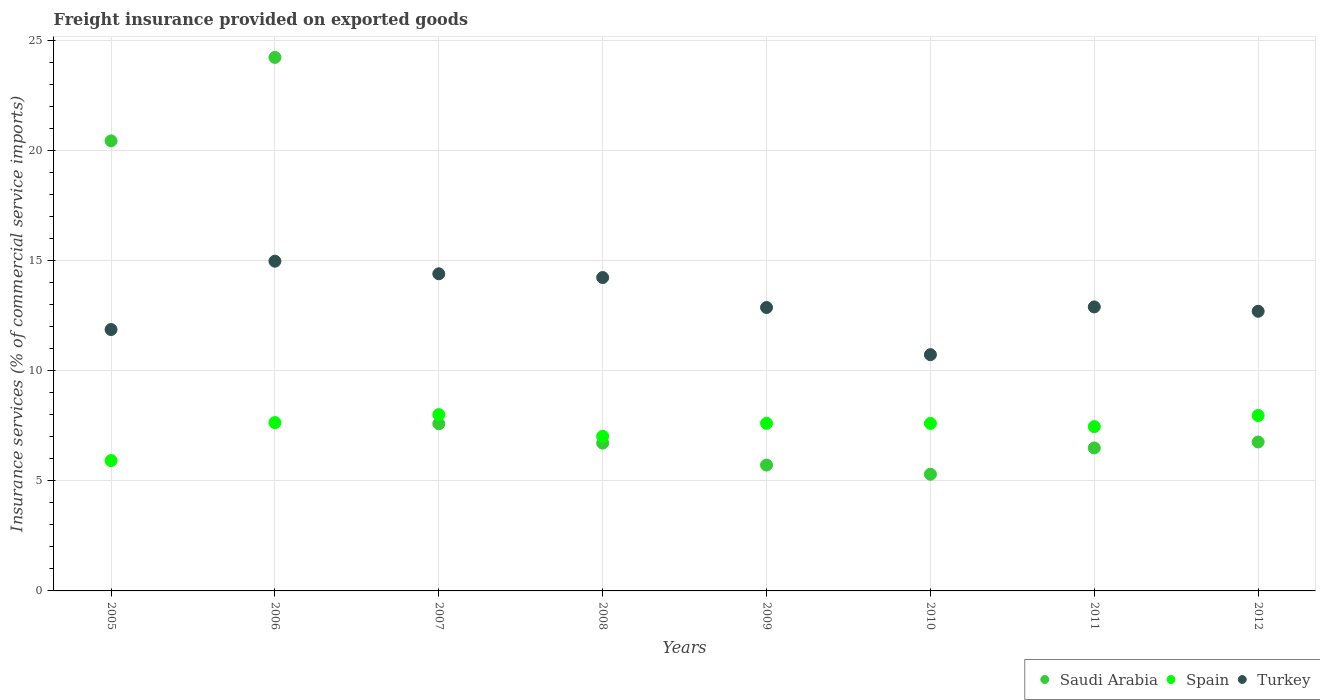What is the freight insurance provided on exported goods in Turkey in 2010?
Make the answer very short. 10.73. Across all years, what is the maximum freight insurance provided on exported goods in Saudi Arabia?
Make the answer very short. 24.23. Across all years, what is the minimum freight insurance provided on exported goods in Saudi Arabia?
Offer a terse response. 5.3. In which year was the freight insurance provided on exported goods in Saudi Arabia minimum?
Keep it short and to the point. 2010. What is the total freight insurance provided on exported goods in Turkey in the graph?
Your answer should be compact. 104.69. What is the difference between the freight insurance provided on exported goods in Spain in 2005 and that in 2006?
Provide a short and direct response. -1.73. What is the difference between the freight insurance provided on exported goods in Spain in 2005 and the freight insurance provided on exported goods in Turkey in 2010?
Your answer should be very brief. -4.81. What is the average freight insurance provided on exported goods in Spain per year?
Keep it short and to the point. 7.41. In the year 2009, what is the difference between the freight insurance provided on exported goods in Turkey and freight insurance provided on exported goods in Spain?
Your response must be concise. 5.26. What is the ratio of the freight insurance provided on exported goods in Turkey in 2008 to that in 2011?
Provide a short and direct response. 1.1. What is the difference between the highest and the second highest freight insurance provided on exported goods in Turkey?
Your answer should be very brief. 0.57. What is the difference between the highest and the lowest freight insurance provided on exported goods in Turkey?
Offer a very short reply. 4.25. In how many years, is the freight insurance provided on exported goods in Turkey greater than the average freight insurance provided on exported goods in Turkey taken over all years?
Your response must be concise. 3. Is the sum of the freight insurance provided on exported goods in Saudi Arabia in 2011 and 2012 greater than the maximum freight insurance provided on exported goods in Spain across all years?
Keep it short and to the point. Yes. Is it the case that in every year, the sum of the freight insurance provided on exported goods in Spain and freight insurance provided on exported goods in Saudi Arabia  is greater than the freight insurance provided on exported goods in Turkey?
Make the answer very short. No. Does the freight insurance provided on exported goods in Spain monotonically increase over the years?
Provide a succinct answer. No. Is the freight insurance provided on exported goods in Saudi Arabia strictly greater than the freight insurance provided on exported goods in Turkey over the years?
Keep it short and to the point. No. How many dotlines are there?
Give a very brief answer. 3. How many years are there in the graph?
Keep it short and to the point. 8. What is the difference between two consecutive major ticks on the Y-axis?
Your answer should be very brief. 5. Are the values on the major ticks of Y-axis written in scientific E-notation?
Offer a very short reply. No. Does the graph contain grids?
Give a very brief answer. Yes. What is the title of the graph?
Offer a terse response. Freight insurance provided on exported goods. What is the label or title of the Y-axis?
Ensure brevity in your answer.  Insurance services (% of commercial service imports). What is the Insurance services (% of commercial service imports) of Saudi Arabia in 2005?
Offer a very short reply. 20.44. What is the Insurance services (% of commercial service imports) in Spain in 2005?
Offer a terse response. 5.92. What is the Insurance services (% of commercial service imports) of Turkey in 2005?
Your answer should be compact. 11.87. What is the Insurance services (% of commercial service imports) of Saudi Arabia in 2006?
Make the answer very short. 24.23. What is the Insurance services (% of commercial service imports) in Spain in 2006?
Give a very brief answer. 7.65. What is the Insurance services (% of commercial service imports) of Turkey in 2006?
Offer a terse response. 14.98. What is the Insurance services (% of commercial service imports) of Saudi Arabia in 2007?
Your response must be concise. 7.59. What is the Insurance services (% of commercial service imports) of Spain in 2007?
Your answer should be very brief. 8.01. What is the Insurance services (% of commercial service imports) in Turkey in 2007?
Offer a terse response. 14.4. What is the Insurance services (% of commercial service imports) in Saudi Arabia in 2008?
Your answer should be very brief. 6.71. What is the Insurance services (% of commercial service imports) in Spain in 2008?
Give a very brief answer. 7.02. What is the Insurance services (% of commercial service imports) of Turkey in 2008?
Keep it short and to the point. 14.23. What is the Insurance services (% of commercial service imports) in Saudi Arabia in 2009?
Provide a succinct answer. 5.72. What is the Insurance services (% of commercial service imports) of Spain in 2009?
Ensure brevity in your answer.  7.61. What is the Insurance services (% of commercial service imports) of Turkey in 2009?
Provide a succinct answer. 12.87. What is the Insurance services (% of commercial service imports) in Saudi Arabia in 2010?
Provide a short and direct response. 5.3. What is the Insurance services (% of commercial service imports) of Spain in 2010?
Make the answer very short. 7.61. What is the Insurance services (% of commercial service imports) of Turkey in 2010?
Your answer should be very brief. 10.73. What is the Insurance services (% of commercial service imports) in Saudi Arabia in 2011?
Your response must be concise. 6.49. What is the Insurance services (% of commercial service imports) in Spain in 2011?
Ensure brevity in your answer.  7.46. What is the Insurance services (% of commercial service imports) of Turkey in 2011?
Provide a short and direct response. 12.9. What is the Insurance services (% of commercial service imports) in Saudi Arabia in 2012?
Provide a succinct answer. 6.76. What is the Insurance services (% of commercial service imports) of Spain in 2012?
Your response must be concise. 7.97. What is the Insurance services (% of commercial service imports) in Turkey in 2012?
Ensure brevity in your answer.  12.7. Across all years, what is the maximum Insurance services (% of commercial service imports) in Saudi Arabia?
Provide a succinct answer. 24.23. Across all years, what is the maximum Insurance services (% of commercial service imports) in Spain?
Give a very brief answer. 8.01. Across all years, what is the maximum Insurance services (% of commercial service imports) in Turkey?
Your response must be concise. 14.98. Across all years, what is the minimum Insurance services (% of commercial service imports) in Saudi Arabia?
Provide a short and direct response. 5.3. Across all years, what is the minimum Insurance services (% of commercial service imports) of Spain?
Make the answer very short. 5.92. Across all years, what is the minimum Insurance services (% of commercial service imports) of Turkey?
Ensure brevity in your answer.  10.73. What is the total Insurance services (% of commercial service imports) of Saudi Arabia in the graph?
Your response must be concise. 83.25. What is the total Insurance services (% of commercial service imports) in Spain in the graph?
Offer a very short reply. 59.25. What is the total Insurance services (% of commercial service imports) of Turkey in the graph?
Make the answer very short. 104.69. What is the difference between the Insurance services (% of commercial service imports) of Saudi Arabia in 2005 and that in 2006?
Give a very brief answer. -3.79. What is the difference between the Insurance services (% of commercial service imports) of Spain in 2005 and that in 2006?
Provide a short and direct response. -1.73. What is the difference between the Insurance services (% of commercial service imports) of Turkey in 2005 and that in 2006?
Your answer should be very brief. -3.1. What is the difference between the Insurance services (% of commercial service imports) of Saudi Arabia in 2005 and that in 2007?
Your answer should be compact. 12.85. What is the difference between the Insurance services (% of commercial service imports) in Spain in 2005 and that in 2007?
Your answer should be compact. -2.09. What is the difference between the Insurance services (% of commercial service imports) of Turkey in 2005 and that in 2007?
Your response must be concise. -2.53. What is the difference between the Insurance services (% of commercial service imports) of Saudi Arabia in 2005 and that in 2008?
Provide a succinct answer. 13.73. What is the difference between the Insurance services (% of commercial service imports) of Spain in 2005 and that in 2008?
Give a very brief answer. -1.1. What is the difference between the Insurance services (% of commercial service imports) of Turkey in 2005 and that in 2008?
Make the answer very short. -2.36. What is the difference between the Insurance services (% of commercial service imports) in Saudi Arabia in 2005 and that in 2009?
Provide a short and direct response. 14.73. What is the difference between the Insurance services (% of commercial service imports) in Spain in 2005 and that in 2009?
Give a very brief answer. -1.69. What is the difference between the Insurance services (% of commercial service imports) of Turkey in 2005 and that in 2009?
Ensure brevity in your answer.  -1. What is the difference between the Insurance services (% of commercial service imports) of Saudi Arabia in 2005 and that in 2010?
Your response must be concise. 15.14. What is the difference between the Insurance services (% of commercial service imports) in Spain in 2005 and that in 2010?
Keep it short and to the point. -1.69. What is the difference between the Insurance services (% of commercial service imports) of Turkey in 2005 and that in 2010?
Give a very brief answer. 1.14. What is the difference between the Insurance services (% of commercial service imports) in Saudi Arabia in 2005 and that in 2011?
Your answer should be compact. 13.95. What is the difference between the Insurance services (% of commercial service imports) of Spain in 2005 and that in 2011?
Your answer should be very brief. -1.54. What is the difference between the Insurance services (% of commercial service imports) of Turkey in 2005 and that in 2011?
Your answer should be compact. -1.03. What is the difference between the Insurance services (% of commercial service imports) in Saudi Arabia in 2005 and that in 2012?
Give a very brief answer. 13.68. What is the difference between the Insurance services (% of commercial service imports) of Spain in 2005 and that in 2012?
Your answer should be compact. -2.05. What is the difference between the Insurance services (% of commercial service imports) of Turkey in 2005 and that in 2012?
Offer a terse response. -0.83. What is the difference between the Insurance services (% of commercial service imports) of Saudi Arabia in 2006 and that in 2007?
Give a very brief answer. 16.64. What is the difference between the Insurance services (% of commercial service imports) of Spain in 2006 and that in 2007?
Keep it short and to the point. -0.36. What is the difference between the Insurance services (% of commercial service imports) in Turkey in 2006 and that in 2007?
Give a very brief answer. 0.57. What is the difference between the Insurance services (% of commercial service imports) of Saudi Arabia in 2006 and that in 2008?
Provide a succinct answer. 17.52. What is the difference between the Insurance services (% of commercial service imports) of Spain in 2006 and that in 2008?
Provide a short and direct response. 0.62. What is the difference between the Insurance services (% of commercial service imports) of Turkey in 2006 and that in 2008?
Your answer should be compact. 0.74. What is the difference between the Insurance services (% of commercial service imports) of Saudi Arabia in 2006 and that in 2009?
Make the answer very short. 18.52. What is the difference between the Insurance services (% of commercial service imports) of Spain in 2006 and that in 2009?
Ensure brevity in your answer.  0.03. What is the difference between the Insurance services (% of commercial service imports) of Turkey in 2006 and that in 2009?
Provide a short and direct response. 2.1. What is the difference between the Insurance services (% of commercial service imports) in Saudi Arabia in 2006 and that in 2010?
Provide a short and direct response. 18.93. What is the difference between the Insurance services (% of commercial service imports) of Spain in 2006 and that in 2010?
Your answer should be very brief. 0.04. What is the difference between the Insurance services (% of commercial service imports) in Turkey in 2006 and that in 2010?
Give a very brief answer. 4.25. What is the difference between the Insurance services (% of commercial service imports) of Saudi Arabia in 2006 and that in 2011?
Your answer should be compact. 17.74. What is the difference between the Insurance services (% of commercial service imports) of Spain in 2006 and that in 2011?
Your answer should be compact. 0.18. What is the difference between the Insurance services (% of commercial service imports) in Turkey in 2006 and that in 2011?
Provide a short and direct response. 2.08. What is the difference between the Insurance services (% of commercial service imports) of Saudi Arabia in 2006 and that in 2012?
Make the answer very short. 17.47. What is the difference between the Insurance services (% of commercial service imports) of Spain in 2006 and that in 2012?
Make the answer very short. -0.32. What is the difference between the Insurance services (% of commercial service imports) in Turkey in 2006 and that in 2012?
Give a very brief answer. 2.27. What is the difference between the Insurance services (% of commercial service imports) in Saudi Arabia in 2007 and that in 2008?
Your answer should be very brief. 0.88. What is the difference between the Insurance services (% of commercial service imports) of Spain in 2007 and that in 2008?
Offer a very short reply. 0.99. What is the difference between the Insurance services (% of commercial service imports) of Turkey in 2007 and that in 2008?
Keep it short and to the point. 0.17. What is the difference between the Insurance services (% of commercial service imports) in Saudi Arabia in 2007 and that in 2009?
Give a very brief answer. 1.88. What is the difference between the Insurance services (% of commercial service imports) of Spain in 2007 and that in 2009?
Your answer should be very brief. 0.4. What is the difference between the Insurance services (% of commercial service imports) of Turkey in 2007 and that in 2009?
Provide a succinct answer. 1.53. What is the difference between the Insurance services (% of commercial service imports) in Saudi Arabia in 2007 and that in 2010?
Provide a succinct answer. 2.29. What is the difference between the Insurance services (% of commercial service imports) of Spain in 2007 and that in 2010?
Your response must be concise. 0.4. What is the difference between the Insurance services (% of commercial service imports) in Turkey in 2007 and that in 2010?
Offer a terse response. 3.67. What is the difference between the Insurance services (% of commercial service imports) of Saudi Arabia in 2007 and that in 2011?
Offer a terse response. 1.1. What is the difference between the Insurance services (% of commercial service imports) in Spain in 2007 and that in 2011?
Provide a succinct answer. 0.55. What is the difference between the Insurance services (% of commercial service imports) of Turkey in 2007 and that in 2011?
Keep it short and to the point. 1.5. What is the difference between the Insurance services (% of commercial service imports) in Saudi Arabia in 2007 and that in 2012?
Your answer should be compact. 0.83. What is the difference between the Insurance services (% of commercial service imports) in Spain in 2007 and that in 2012?
Provide a short and direct response. 0.04. What is the difference between the Insurance services (% of commercial service imports) of Turkey in 2007 and that in 2012?
Your response must be concise. 1.7. What is the difference between the Insurance services (% of commercial service imports) in Spain in 2008 and that in 2009?
Provide a succinct answer. -0.59. What is the difference between the Insurance services (% of commercial service imports) in Turkey in 2008 and that in 2009?
Make the answer very short. 1.36. What is the difference between the Insurance services (% of commercial service imports) in Saudi Arabia in 2008 and that in 2010?
Keep it short and to the point. 1.41. What is the difference between the Insurance services (% of commercial service imports) in Spain in 2008 and that in 2010?
Make the answer very short. -0.59. What is the difference between the Insurance services (% of commercial service imports) of Turkey in 2008 and that in 2010?
Keep it short and to the point. 3.5. What is the difference between the Insurance services (% of commercial service imports) in Saudi Arabia in 2008 and that in 2011?
Provide a short and direct response. 0.22. What is the difference between the Insurance services (% of commercial service imports) in Spain in 2008 and that in 2011?
Offer a very short reply. -0.44. What is the difference between the Insurance services (% of commercial service imports) in Turkey in 2008 and that in 2011?
Give a very brief answer. 1.33. What is the difference between the Insurance services (% of commercial service imports) in Saudi Arabia in 2008 and that in 2012?
Your answer should be compact. -0.05. What is the difference between the Insurance services (% of commercial service imports) in Spain in 2008 and that in 2012?
Ensure brevity in your answer.  -0.95. What is the difference between the Insurance services (% of commercial service imports) of Turkey in 2008 and that in 2012?
Your response must be concise. 1.53. What is the difference between the Insurance services (% of commercial service imports) of Saudi Arabia in 2009 and that in 2010?
Ensure brevity in your answer.  0.42. What is the difference between the Insurance services (% of commercial service imports) in Spain in 2009 and that in 2010?
Make the answer very short. 0. What is the difference between the Insurance services (% of commercial service imports) of Turkey in 2009 and that in 2010?
Keep it short and to the point. 2.14. What is the difference between the Insurance services (% of commercial service imports) in Saudi Arabia in 2009 and that in 2011?
Ensure brevity in your answer.  -0.78. What is the difference between the Insurance services (% of commercial service imports) in Spain in 2009 and that in 2011?
Your response must be concise. 0.15. What is the difference between the Insurance services (% of commercial service imports) in Turkey in 2009 and that in 2011?
Offer a terse response. -0.03. What is the difference between the Insurance services (% of commercial service imports) in Saudi Arabia in 2009 and that in 2012?
Offer a very short reply. -1.05. What is the difference between the Insurance services (% of commercial service imports) of Spain in 2009 and that in 2012?
Provide a succinct answer. -0.35. What is the difference between the Insurance services (% of commercial service imports) of Turkey in 2009 and that in 2012?
Your response must be concise. 0.17. What is the difference between the Insurance services (% of commercial service imports) of Saudi Arabia in 2010 and that in 2011?
Provide a short and direct response. -1.19. What is the difference between the Insurance services (% of commercial service imports) of Spain in 2010 and that in 2011?
Provide a short and direct response. 0.15. What is the difference between the Insurance services (% of commercial service imports) in Turkey in 2010 and that in 2011?
Give a very brief answer. -2.17. What is the difference between the Insurance services (% of commercial service imports) in Saudi Arabia in 2010 and that in 2012?
Ensure brevity in your answer.  -1.46. What is the difference between the Insurance services (% of commercial service imports) of Spain in 2010 and that in 2012?
Your answer should be compact. -0.36. What is the difference between the Insurance services (% of commercial service imports) in Turkey in 2010 and that in 2012?
Make the answer very short. -1.97. What is the difference between the Insurance services (% of commercial service imports) of Saudi Arabia in 2011 and that in 2012?
Make the answer very short. -0.27. What is the difference between the Insurance services (% of commercial service imports) of Spain in 2011 and that in 2012?
Give a very brief answer. -0.5. What is the difference between the Insurance services (% of commercial service imports) in Turkey in 2011 and that in 2012?
Offer a very short reply. 0.2. What is the difference between the Insurance services (% of commercial service imports) of Saudi Arabia in 2005 and the Insurance services (% of commercial service imports) of Spain in 2006?
Offer a very short reply. 12.8. What is the difference between the Insurance services (% of commercial service imports) of Saudi Arabia in 2005 and the Insurance services (% of commercial service imports) of Turkey in 2006?
Make the answer very short. 5.46. What is the difference between the Insurance services (% of commercial service imports) in Spain in 2005 and the Insurance services (% of commercial service imports) in Turkey in 2006?
Your response must be concise. -9.06. What is the difference between the Insurance services (% of commercial service imports) in Saudi Arabia in 2005 and the Insurance services (% of commercial service imports) in Spain in 2007?
Provide a short and direct response. 12.43. What is the difference between the Insurance services (% of commercial service imports) of Saudi Arabia in 2005 and the Insurance services (% of commercial service imports) of Turkey in 2007?
Give a very brief answer. 6.04. What is the difference between the Insurance services (% of commercial service imports) in Spain in 2005 and the Insurance services (% of commercial service imports) in Turkey in 2007?
Your answer should be very brief. -8.48. What is the difference between the Insurance services (% of commercial service imports) of Saudi Arabia in 2005 and the Insurance services (% of commercial service imports) of Spain in 2008?
Offer a terse response. 13.42. What is the difference between the Insurance services (% of commercial service imports) in Saudi Arabia in 2005 and the Insurance services (% of commercial service imports) in Turkey in 2008?
Provide a succinct answer. 6.21. What is the difference between the Insurance services (% of commercial service imports) in Spain in 2005 and the Insurance services (% of commercial service imports) in Turkey in 2008?
Keep it short and to the point. -8.31. What is the difference between the Insurance services (% of commercial service imports) of Saudi Arabia in 2005 and the Insurance services (% of commercial service imports) of Spain in 2009?
Ensure brevity in your answer.  12.83. What is the difference between the Insurance services (% of commercial service imports) of Saudi Arabia in 2005 and the Insurance services (% of commercial service imports) of Turkey in 2009?
Make the answer very short. 7.57. What is the difference between the Insurance services (% of commercial service imports) of Spain in 2005 and the Insurance services (% of commercial service imports) of Turkey in 2009?
Give a very brief answer. -6.95. What is the difference between the Insurance services (% of commercial service imports) in Saudi Arabia in 2005 and the Insurance services (% of commercial service imports) in Spain in 2010?
Ensure brevity in your answer.  12.83. What is the difference between the Insurance services (% of commercial service imports) in Saudi Arabia in 2005 and the Insurance services (% of commercial service imports) in Turkey in 2010?
Offer a very short reply. 9.71. What is the difference between the Insurance services (% of commercial service imports) of Spain in 2005 and the Insurance services (% of commercial service imports) of Turkey in 2010?
Your response must be concise. -4.81. What is the difference between the Insurance services (% of commercial service imports) of Saudi Arabia in 2005 and the Insurance services (% of commercial service imports) of Spain in 2011?
Provide a short and direct response. 12.98. What is the difference between the Insurance services (% of commercial service imports) of Saudi Arabia in 2005 and the Insurance services (% of commercial service imports) of Turkey in 2011?
Make the answer very short. 7.54. What is the difference between the Insurance services (% of commercial service imports) of Spain in 2005 and the Insurance services (% of commercial service imports) of Turkey in 2011?
Your response must be concise. -6.98. What is the difference between the Insurance services (% of commercial service imports) of Saudi Arabia in 2005 and the Insurance services (% of commercial service imports) of Spain in 2012?
Your answer should be compact. 12.47. What is the difference between the Insurance services (% of commercial service imports) of Saudi Arabia in 2005 and the Insurance services (% of commercial service imports) of Turkey in 2012?
Your response must be concise. 7.74. What is the difference between the Insurance services (% of commercial service imports) of Spain in 2005 and the Insurance services (% of commercial service imports) of Turkey in 2012?
Provide a short and direct response. -6.78. What is the difference between the Insurance services (% of commercial service imports) in Saudi Arabia in 2006 and the Insurance services (% of commercial service imports) in Spain in 2007?
Make the answer very short. 16.22. What is the difference between the Insurance services (% of commercial service imports) of Saudi Arabia in 2006 and the Insurance services (% of commercial service imports) of Turkey in 2007?
Your answer should be very brief. 9.83. What is the difference between the Insurance services (% of commercial service imports) in Spain in 2006 and the Insurance services (% of commercial service imports) in Turkey in 2007?
Keep it short and to the point. -6.76. What is the difference between the Insurance services (% of commercial service imports) in Saudi Arabia in 2006 and the Insurance services (% of commercial service imports) in Spain in 2008?
Your answer should be compact. 17.21. What is the difference between the Insurance services (% of commercial service imports) of Saudi Arabia in 2006 and the Insurance services (% of commercial service imports) of Turkey in 2008?
Ensure brevity in your answer.  10. What is the difference between the Insurance services (% of commercial service imports) in Spain in 2006 and the Insurance services (% of commercial service imports) in Turkey in 2008?
Offer a terse response. -6.59. What is the difference between the Insurance services (% of commercial service imports) of Saudi Arabia in 2006 and the Insurance services (% of commercial service imports) of Spain in 2009?
Your answer should be very brief. 16.62. What is the difference between the Insurance services (% of commercial service imports) of Saudi Arabia in 2006 and the Insurance services (% of commercial service imports) of Turkey in 2009?
Provide a short and direct response. 11.36. What is the difference between the Insurance services (% of commercial service imports) in Spain in 2006 and the Insurance services (% of commercial service imports) in Turkey in 2009?
Provide a short and direct response. -5.23. What is the difference between the Insurance services (% of commercial service imports) in Saudi Arabia in 2006 and the Insurance services (% of commercial service imports) in Spain in 2010?
Make the answer very short. 16.62. What is the difference between the Insurance services (% of commercial service imports) in Saudi Arabia in 2006 and the Insurance services (% of commercial service imports) in Turkey in 2010?
Make the answer very short. 13.5. What is the difference between the Insurance services (% of commercial service imports) in Spain in 2006 and the Insurance services (% of commercial service imports) in Turkey in 2010?
Provide a short and direct response. -3.09. What is the difference between the Insurance services (% of commercial service imports) in Saudi Arabia in 2006 and the Insurance services (% of commercial service imports) in Spain in 2011?
Offer a terse response. 16.77. What is the difference between the Insurance services (% of commercial service imports) of Saudi Arabia in 2006 and the Insurance services (% of commercial service imports) of Turkey in 2011?
Make the answer very short. 11.33. What is the difference between the Insurance services (% of commercial service imports) of Spain in 2006 and the Insurance services (% of commercial service imports) of Turkey in 2011?
Keep it short and to the point. -5.25. What is the difference between the Insurance services (% of commercial service imports) in Saudi Arabia in 2006 and the Insurance services (% of commercial service imports) in Spain in 2012?
Keep it short and to the point. 16.27. What is the difference between the Insurance services (% of commercial service imports) of Saudi Arabia in 2006 and the Insurance services (% of commercial service imports) of Turkey in 2012?
Give a very brief answer. 11.53. What is the difference between the Insurance services (% of commercial service imports) in Spain in 2006 and the Insurance services (% of commercial service imports) in Turkey in 2012?
Make the answer very short. -5.06. What is the difference between the Insurance services (% of commercial service imports) of Saudi Arabia in 2007 and the Insurance services (% of commercial service imports) of Spain in 2008?
Provide a succinct answer. 0.57. What is the difference between the Insurance services (% of commercial service imports) in Saudi Arabia in 2007 and the Insurance services (% of commercial service imports) in Turkey in 2008?
Ensure brevity in your answer.  -6.64. What is the difference between the Insurance services (% of commercial service imports) in Spain in 2007 and the Insurance services (% of commercial service imports) in Turkey in 2008?
Provide a short and direct response. -6.23. What is the difference between the Insurance services (% of commercial service imports) of Saudi Arabia in 2007 and the Insurance services (% of commercial service imports) of Spain in 2009?
Ensure brevity in your answer.  -0.02. What is the difference between the Insurance services (% of commercial service imports) of Saudi Arabia in 2007 and the Insurance services (% of commercial service imports) of Turkey in 2009?
Your answer should be compact. -5.28. What is the difference between the Insurance services (% of commercial service imports) in Spain in 2007 and the Insurance services (% of commercial service imports) in Turkey in 2009?
Keep it short and to the point. -4.86. What is the difference between the Insurance services (% of commercial service imports) of Saudi Arabia in 2007 and the Insurance services (% of commercial service imports) of Spain in 2010?
Provide a succinct answer. -0.02. What is the difference between the Insurance services (% of commercial service imports) in Saudi Arabia in 2007 and the Insurance services (% of commercial service imports) in Turkey in 2010?
Make the answer very short. -3.14. What is the difference between the Insurance services (% of commercial service imports) of Spain in 2007 and the Insurance services (% of commercial service imports) of Turkey in 2010?
Your response must be concise. -2.72. What is the difference between the Insurance services (% of commercial service imports) in Saudi Arabia in 2007 and the Insurance services (% of commercial service imports) in Spain in 2011?
Offer a terse response. 0.13. What is the difference between the Insurance services (% of commercial service imports) in Saudi Arabia in 2007 and the Insurance services (% of commercial service imports) in Turkey in 2011?
Your answer should be compact. -5.31. What is the difference between the Insurance services (% of commercial service imports) of Spain in 2007 and the Insurance services (% of commercial service imports) of Turkey in 2011?
Make the answer very short. -4.89. What is the difference between the Insurance services (% of commercial service imports) of Saudi Arabia in 2007 and the Insurance services (% of commercial service imports) of Spain in 2012?
Your response must be concise. -0.37. What is the difference between the Insurance services (% of commercial service imports) of Saudi Arabia in 2007 and the Insurance services (% of commercial service imports) of Turkey in 2012?
Provide a succinct answer. -5.11. What is the difference between the Insurance services (% of commercial service imports) in Spain in 2007 and the Insurance services (% of commercial service imports) in Turkey in 2012?
Keep it short and to the point. -4.69. What is the difference between the Insurance services (% of commercial service imports) of Saudi Arabia in 2008 and the Insurance services (% of commercial service imports) of Spain in 2009?
Your response must be concise. -0.9. What is the difference between the Insurance services (% of commercial service imports) of Saudi Arabia in 2008 and the Insurance services (% of commercial service imports) of Turkey in 2009?
Offer a very short reply. -6.16. What is the difference between the Insurance services (% of commercial service imports) in Spain in 2008 and the Insurance services (% of commercial service imports) in Turkey in 2009?
Offer a terse response. -5.85. What is the difference between the Insurance services (% of commercial service imports) of Saudi Arabia in 2008 and the Insurance services (% of commercial service imports) of Spain in 2010?
Your answer should be very brief. -0.9. What is the difference between the Insurance services (% of commercial service imports) of Saudi Arabia in 2008 and the Insurance services (% of commercial service imports) of Turkey in 2010?
Provide a short and direct response. -4.02. What is the difference between the Insurance services (% of commercial service imports) in Spain in 2008 and the Insurance services (% of commercial service imports) in Turkey in 2010?
Offer a terse response. -3.71. What is the difference between the Insurance services (% of commercial service imports) in Saudi Arabia in 2008 and the Insurance services (% of commercial service imports) in Spain in 2011?
Give a very brief answer. -0.75. What is the difference between the Insurance services (% of commercial service imports) of Saudi Arabia in 2008 and the Insurance services (% of commercial service imports) of Turkey in 2011?
Make the answer very short. -6.19. What is the difference between the Insurance services (% of commercial service imports) in Spain in 2008 and the Insurance services (% of commercial service imports) in Turkey in 2011?
Your answer should be compact. -5.88. What is the difference between the Insurance services (% of commercial service imports) of Saudi Arabia in 2008 and the Insurance services (% of commercial service imports) of Spain in 2012?
Your response must be concise. -1.25. What is the difference between the Insurance services (% of commercial service imports) in Saudi Arabia in 2008 and the Insurance services (% of commercial service imports) in Turkey in 2012?
Make the answer very short. -5.99. What is the difference between the Insurance services (% of commercial service imports) in Spain in 2008 and the Insurance services (% of commercial service imports) in Turkey in 2012?
Offer a very short reply. -5.68. What is the difference between the Insurance services (% of commercial service imports) in Saudi Arabia in 2009 and the Insurance services (% of commercial service imports) in Spain in 2010?
Provide a short and direct response. -1.89. What is the difference between the Insurance services (% of commercial service imports) of Saudi Arabia in 2009 and the Insurance services (% of commercial service imports) of Turkey in 2010?
Ensure brevity in your answer.  -5.01. What is the difference between the Insurance services (% of commercial service imports) in Spain in 2009 and the Insurance services (% of commercial service imports) in Turkey in 2010?
Offer a very short reply. -3.12. What is the difference between the Insurance services (% of commercial service imports) of Saudi Arabia in 2009 and the Insurance services (% of commercial service imports) of Spain in 2011?
Provide a short and direct response. -1.75. What is the difference between the Insurance services (% of commercial service imports) of Saudi Arabia in 2009 and the Insurance services (% of commercial service imports) of Turkey in 2011?
Your answer should be compact. -7.18. What is the difference between the Insurance services (% of commercial service imports) of Spain in 2009 and the Insurance services (% of commercial service imports) of Turkey in 2011?
Your answer should be very brief. -5.29. What is the difference between the Insurance services (% of commercial service imports) of Saudi Arabia in 2009 and the Insurance services (% of commercial service imports) of Spain in 2012?
Make the answer very short. -2.25. What is the difference between the Insurance services (% of commercial service imports) of Saudi Arabia in 2009 and the Insurance services (% of commercial service imports) of Turkey in 2012?
Keep it short and to the point. -6.99. What is the difference between the Insurance services (% of commercial service imports) of Spain in 2009 and the Insurance services (% of commercial service imports) of Turkey in 2012?
Your answer should be compact. -5.09. What is the difference between the Insurance services (% of commercial service imports) in Saudi Arabia in 2010 and the Insurance services (% of commercial service imports) in Spain in 2011?
Your response must be concise. -2.16. What is the difference between the Insurance services (% of commercial service imports) in Saudi Arabia in 2010 and the Insurance services (% of commercial service imports) in Turkey in 2011?
Make the answer very short. -7.6. What is the difference between the Insurance services (% of commercial service imports) in Spain in 2010 and the Insurance services (% of commercial service imports) in Turkey in 2011?
Your answer should be very brief. -5.29. What is the difference between the Insurance services (% of commercial service imports) of Saudi Arabia in 2010 and the Insurance services (% of commercial service imports) of Spain in 2012?
Keep it short and to the point. -2.67. What is the difference between the Insurance services (% of commercial service imports) in Saudi Arabia in 2010 and the Insurance services (% of commercial service imports) in Turkey in 2012?
Your response must be concise. -7.4. What is the difference between the Insurance services (% of commercial service imports) of Spain in 2010 and the Insurance services (% of commercial service imports) of Turkey in 2012?
Ensure brevity in your answer.  -5.09. What is the difference between the Insurance services (% of commercial service imports) in Saudi Arabia in 2011 and the Insurance services (% of commercial service imports) in Spain in 2012?
Keep it short and to the point. -1.47. What is the difference between the Insurance services (% of commercial service imports) of Saudi Arabia in 2011 and the Insurance services (% of commercial service imports) of Turkey in 2012?
Make the answer very short. -6.21. What is the difference between the Insurance services (% of commercial service imports) in Spain in 2011 and the Insurance services (% of commercial service imports) in Turkey in 2012?
Provide a short and direct response. -5.24. What is the average Insurance services (% of commercial service imports) of Saudi Arabia per year?
Provide a succinct answer. 10.41. What is the average Insurance services (% of commercial service imports) in Spain per year?
Keep it short and to the point. 7.41. What is the average Insurance services (% of commercial service imports) in Turkey per year?
Keep it short and to the point. 13.09. In the year 2005, what is the difference between the Insurance services (% of commercial service imports) of Saudi Arabia and Insurance services (% of commercial service imports) of Spain?
Give a very brief answer. 14.52. In the year 2005, what is the difference between the Insurance services (% of commercial service imports) in Saudi Arabia and Insurance services (% of commercial service imports) in Turkey?
Ensure brevity in your answer.  8.57. In the year 2005, what is the difference between the Insurance services (% of commercial service imports) in Spain and Insurance services (% of commercial service imports) in Turkey?
Give a very brief answer. -5.95. In the year 2006, what is the difference between the Insurance services (% of commercial service imports) in Saudi Arabia and Insurance services (% of commercial service imports) in Spain?
Ensure brevity in your answer.  16.59. In the year 2006, what is the difference between the Insurance services (% of commercial service imports) of Saudi Arabia and Insurance services (% of commercial service imports) of Turkey?
Provide a short and direct response. 9.26. In the year 2006, what is the difference between the Insurance services (% of commercial service imports) of Spain and Insurance services (% of commercial service imports) of Turkey?
Offer a very short reply. -7.33. In the year 2007, what is the difference between the Insurance services (% of commercial service imports) in Saudi Arabia and Insurance services (% of commercial service imports) in Spain?
Your response must be concise. -0.42. In the year 2007, what is the difference between the Insurance services (% of commercial service imports) of Saudi Arabia and Insurance services (% of commercial service imports) of Turkey?
Give a very brief answer. -6.81. In the year 2007, what is the difference between the Insurance services (% of commercial service imports) of Spain and Insurance services (% of commercial service imports) of Turkey?
Your answer should be compact. -6.4. In the year 2008, what is the difference between the Insurance services (% of commercial service imports) of Saudi Arabia and Insurance services (% of commercial service imports) of Spain?
Offer a terse response. -0.31. In the year 2008, what is the difference between the Insurance services (% of commercial service imports) of Saudi Arabia and Insurance services (% of commercial service imports) of Turkey?
Offer a very short reply. -7.52. In the year 2008, what is the difference between the Insurance services (% of commercial service imports) of Spain and Insurance services (% of commercial service imports) of Turkey?
Provide a succinct answer. -7.21. In the year 2009, what is the difference between the Insurance services (% of commercial service imports) of Saudi Arabia and Insurance services (% of commercial service imports) of Spain?
Ensure brevity in your answer.  -1.9. In the year 2009, what is the difference between the Insurance services (% of commercial service imports) of Saudi Arabia and Insurance services (% of commercial service imports) of Turkey?
Your answer should be compact. -7.16. In the year 2009, what is the difference between the Insurance services (% of commercial service imports) in Spain and Insurance services (% of commercial service imports) in Turkey?
Make the answer very short. -5.26. In the year 2010, what is the difference between the Insurance services (% of commercial service imports) of Saudi Arabia and Insurance services (% of commercial service imports) of Spain?
Your response must be concise. -2.31. In the year 2010, what is the difference between the Insurance services (% of commercial service imports) in Saudi Arabia and Insurance services (% of commercial service imports) in Turkey?
Your answer should be very brief. -5.43. In the year 2010, what is the difference between the Insurance services (% of commercial service imports) of Spain and Insurance services (% of commercial service imports) of Turkey?
Your response must be concise. -3.12. In the year 2011, what is the difference between the Insurance services (% of commercial service imports) in Saudi Arabia and Insurance services (% of commercial service imports) in Spain?
Provide a succinct answer. -0.97. In the year 2011, what is the difference between the Insurance services (% of commercial service imports) in Saudi Arabia and Insurance services (% of commercial service imports) in Turkey?
Provide a succinct answer. -6.41. In the year 2011, what is the difference between the Insurance services (% of commercial service imports) of Spain and Insurance services (% of commercial service imports) of Turkey?
Ensure brevity in your answer.  -5.44. In the year 2012, what is the difference between the Insurance services (% of commercial service imports) of Saudi Arabia and Insurance services (% of commercial service imports) of Spain?
Your answer should be compact. -1.2. In the year 2012, what is the difference between the Insurance services (% of commercial service imports) of Saudi Arabia and Insurance services (% of commercial service imports) of Turkey?
Keep it short and to the point. -5.94. In the year 2012, what is the difference between the Insurance services (% of commercial service imports) of Spain and Insurance services (% of commercial service imports) of Turkey?
Ensure brevity in your answer.  -4.74. What is the ratio of the Insurance services (% of commercial service imports) in Saudi Arabia in 2005 to that in 2006?
Give a very brief answer. 0.84. What is the ratio of the Insurance services (% of commercial service imports) in Spain in 2005 to that in 2006?
Your response must be concise. 0.77. What is the ratio of the Insurance services (% of commercial service imports) in Turkey in 2005 to that in 2006?
Ensure brevity in your answer.  0.79. What is the ratio of the Insurance services (% of commercial service imports) of Saudi Arabia in 2005 to that in 2007?
Provide a succinct answer. 2.69. What is the ratio of the Insurance services (% of commercial service imports) in Spain in 2005 to that in 2007?
Ensure brevity in your answer.  0.74. What is the ratio of the Insurance services (% of commercial service imports) of Turkey in 2005 to that in 2007?
Keep it short and to the point. 0.82. What is the ratio of the Insurance services (% of commercial service imports) of Saudi Arabia in 2005 to that in 2008?
Provide a short and direct response. 3.04. What is the ratio of the Insurance services (% of commercial service imports) of Spain in 2005 to that in 2008?
Offer a terse response. 0.84. What is the ratio of the Insurance services (% of commercial service imports) in Turkey in 2005 to that in 2008?
Provide a short and direct response. 0.83. What is the ratio of the Insurance services (% of commercial service imports) in Saudi Arabia in 2005 to that in 2009?
Give a very brief answer. 3.58. What is the ratio of the Insurance services (% of commercial service imports) of Spain in 2005 to that in 2009?
Your answer should be compact. 0.78. What is the ratio of the Insurance services (% of commercial service imports) in Turkey in 2005 to that in 2009?
Provide a succinct answer. 0.92. What is the ratio of the Insurance services (% of commercial service imports) of Saudi Arabia in 2005 to that in 2010?
Offer a terse response. 3.86. What is the ratio of the Insurance services (% of commercial service imports) in Spain in 2005 to that in 2010?
Give a very brief answer. 0.78. What is the ratio of the Insurance services (% of commercial service imports) of Turkey in 2005 to that in 2010?
Ensure brevity in your answer.  1.11. What is the ratio of the Insurance services (% of commercial service imports) in Saudi Arabia in 2005 to that in 2011?
Offer a terse response. 3.15. What is the ratio of the Insurance services (% of commercial service imports) in Spain in 2005 to that in 2011?
Provide a short and direct response. 0.79. What is the ratio of the Insurance services (% of commercial service imports) of Turkey in 2005 to that in 2011?
Keep it short and to the point. 0.92. What is the ratio of the Insurance services (% of commercial service imports) in Saudi Arabia in 2005 to that in 2012?
Offer a terse response. 3.02. What is the ratio of the Insurance services (% of commercial service imports) in Spain in 2005 to that in 2012?
Offer a very short reply. 0.74. What is the ratio of the Insurance services (% of commercial service imports) of Turkey in 2005 to that in 2012?
Your response must be concise. 0.93. What is the ratio of the Insurance services (% of commercial service imports) of Saudi Arabia in 2006 to that in 2007?
Provide a succinct answer. 3.19. What is the ratio of the Insurance services (% of commercial service imports) in Spain in 2006 to that in 2007?
Your response must be concise. 0.95. What is the ratio of the Insurance services (% of commercial service imports) of Turkey in 2006 to that in 2007?
Offer a very short reply. 1.04. What is the ratio of the Insurance services (% of commercial service imports) of Saudi Arabia in 2006 to that in 2008?
Give a very brief answer. 3.61. What is the ratio of the Insurance services (% of commercial service imports) in Spain in 2006 to that in 2008?
Ensure brevity in your answer.  1.09. What is the ratio of the Insurance services (% of commercial service imports) of Turkey in 2006 to that in 2008?
Offer a terse response. 1.05. What is the ratio of the Insurance services (% of commercial service imports) of Saudi Arabia in 2006 to that in 2009?
Offer a terse response. 4.24. What is the ratio of the Insurance services (% of commercial service imports) in Turkey in 2006 to that in 2009?
Ensure brevity in your answer.  1.16. What is the ratio of the Insurance services (% of commercial service imports) of Saudi Arabia in 2006 to that in 2010?
Your answer should be compact. 4.57. What is the ratio of the Insurance services (% of commercial service imports) in Spain in 2006 to that in 2010?
Keep it short and to the point. 1. What is the ratio of the Insurance services (% of commercial service imports) in Turkey in 2006 to that in 2010?
Your answer should be compact. 1.4. What is the ratio of the Insurance services (% of commercial service imports) in Saudi Arabia in 2006 to that in 2011?
Ensure brevity in your answer.  3.73. What is the ratio of the Insurance services (% of commercial service imports) in Spain in 2006 to that in 2011?
Your response must be concise. 1.02. What is the ratio of the Insurance services (% of commercial service imports) in Turkey in 2006 to that in 2011?
Your response must be concise. 1.16. What is the ratio of the Insurance services (% of commercial service imports) in Saudi Arabia in 2006 to that in 2012?
Offer a very short reply. 3.58. What is the ratio of the Insurance services (% of commercial service imports) in Spain in 2006 to that in 2012?
Provide a succinct answer. 0.96. What is the ratio of the Insurance services (% of commercial service imports) of Turkey in 2006 to that in 2012?
Your answer should be compact. 1.18. What is the ratio of the Insurance services (% of commercial service imports) of Saudi Arabia in 2007 to that in 2008?
Your answer should be compact. 1.13. What is the ratio of the Insurance services (% of commercial service imports) in Spain in 2007 to that in 2008?
Provide a succinct answer. 1.14. What is the ratio of the Insurance services (% of commercial service imports) of Turkey in 2007 to that in 2008?
Your answer should be compact. 1.01. What is the ratio of the Insurance services (% of commercial service imports) of Saudi Arabia in 2007 to that in 2009?
Provide a succinct answer. 1.33. What is the ratio of the Insurance services (% of commercial service imports) of Spain in 2007 to that in 2009?
Your answer should be very brief. 1.05. What is the ratio of the Insurance services (% of commercial service imports) in Turkey in 2007 to that in 2009?
Your answer should be compact. 1.12. What is the ratio of the Insurance services (% of commercial service imports) in Saudi Arabia in 2007 to that in 2010?
Your answer should be compact. 1.43. What is the ratio of the Insurance services (% of commercial service imports) of Spain in 2007 to that in 2010?
Offer a very short reply. 1.05. What is the ratio of the Insurance services (% of commercial service imports) of Turkey in 2007 to that in 2010?
Your answer should be very brief. 1.34. What is the ratio of the Insurance services (% of commercial service imports) in Saudi Arabia in 2007 to that in 2011?
Provide a succinct answer. 1.17. What is the ratio of the Insurance services (% of commercial service imports) of Spain in 2007 to that in 2011?
Give a very brief answer. 1.07. What is the ratio of the Insurance services (% of commercial service imports) in Turkey in 2007 to that in 2011?
Your response must be concise. 1.12. What is the ratio of the Insurance services (% of commercial service imports) in Saudi Arabia in 2007 to that in 2012?
Offer a terse response. 1.12. What is the ratio of the Insurance services (% of commercial service imports) of Turkey in 2007 to that in 2012?
Offer a very short reply. 1.13. What is the ratio of the Insurance services (% of commercial service imports) in Saudi Arabia in 2008 to that in 2009?
Make the answer very short. 1.17. What is the ratio of the Insurance services (% of commercial service imports) of Spain in 2008 to that in 2009?
Keep it short and to the point. 0.92. What is the ratio of the Insurance services (% of commercial service imports) in Turkey in 2008 to that in 2009?
Offer a terse response. 1.11. What is the ratio of the Insurance services (% of commercial service imports) of Saudi Arabia in 2008 to that in 2010?
Provide a short and direct response. 1.27. What is the ratio of the Insurance services (% of commercial service imports) in Spain in 2008 to that in 2010?
Offer a very short reply. 0.92. What is the ratio of the Insurance services (% of commercial service imports) of Turkey in 2008 to that in 2010?
Your answer should be compact. 1.33. What is the ratio of the Insurance services (% of commercial service imports) of Saudi Arabia in 2008 to that in 2011?
Provide a succinct answer. 1.03. What is the ratio of the Insurance services (% of commercial service imports) in Spain in 2008 to that in 2011?
Your answer should be compact. 0.94. What is the ratio of the Insurance services (% of commercial service imports) in Turkey in 2008 to that in 2011?
Provide a succinct answer. 1.1. What is the ratio of the Insurance services (% of commercial service imports) of Spain in 2008 to that in 2012?
Ensure brevity in your answer.  0.88. What is the ratio of the Insurance services (% of commercial service imports) in Turkey in 2008 to that in 2012?
Keep it short and to the point. 1.12. What is the ratio of the Insurance services (% of commercial service imports) of Saudi Arabia in 2009 to that in 2010?
Your answer should be compact. 1.08. What is the ratio of the Insurance services (% of commercial service imports) of Turkey in 2009 to that in 2010?
Offer a terse response. 1.2. What is the ratio of the Insurance services (% of commercial service imports) of Saudi Arabia in 2009 to that in 2011?
Your answer should be very brief. 0.88. What is the ratio of the Insurance services (% of commercial service imports) in Spain in 2009 to that in 2011?
Provide a succinct answer. 1.02. What is the ratio of the Insurance services (% of commercial service imports) in Saudi Arabia in 2009 to that in 2012?
Give a very brief answer. 0.85. What is the ratio of the Insurance services (% of commercial service imports) of Spain in 2009 to that in 2012?
Ensure brevity in your answer.  0.96. What is the ratio of the Insurance services (% of commercial service imports) of Turkey in 2009 to that in 2012?
Your answer should be very brief. 1.01. What is the ratio of the Insurance services (% of commercial service imports) in Saudi Arabia in 2010 to that in 2011?
Your answer should be compact. 0.82. What is the ratio of the Insurance services (% of commercial service imports) in Spain in 2010 to that in 2011?
Your answer should be very brief. 1.02. What is the ratio of the Insurance services (% of commercial service imports) of Turkey in 2010 to that in 2011?
Your answer should be compact. 0.83. What is the ratio of the Insurance services (% of commercial service imports) in Saudi Arabia in 2010 to that in 2012?
Provide a short and direct response. 0.78. What is the ratio of the Insurance services (% of commercial service imports) in Spain in 2010 to that in 2012?
Your response must be concise. 0.96. What is the ratio of the Insurance services (% of commercial service imports) in Turkey in 2010 to that in 2012?
Provide a succinct answer. 0.84. What is the ratio of the Insurance services (% of commercial service imports) of Saudi Arabia in 2011 to that in 2012?
Keep it short and to the point. 0.96. What is the ratio of the Insurance services (% of commercial service imports) of Spain in 2011 to that in 2012?
Your answer should be compact. 0.94. What is the ratio of the Insurance services (% of commercial service imports) of Turkey in 2011 to that in 2012?
Ensure brevity in your answer.  1.02. What is the difference between the highest and the second highest Insurance services (% of commercial service imports) in Saudi Arabia?
Your response must be concise. 3.79. What is the difference between the highest and the second highest Insurance services (% of commercial service imports) in Spain?
Your answer should be compact. 0.04. What is the difference between the highest and the second highest Insurance services (% of commercial service imports) in Turkey?
Offer a very short reply. 0.57. What is the difference between the highest and the lowest Insurance services (% of commercial service imports) in Saudi Arabia?
Offer a terse response. 18.93. What is the difference between the highest and the lowest Insurance services (% of commercial service imports) in Spain?
Your answer should be compact. 2.09. What is the difference between the highest and the lowest Insurance services (% of commercial service imports) in Turkey?
Offer a very short reply. 4.25. 